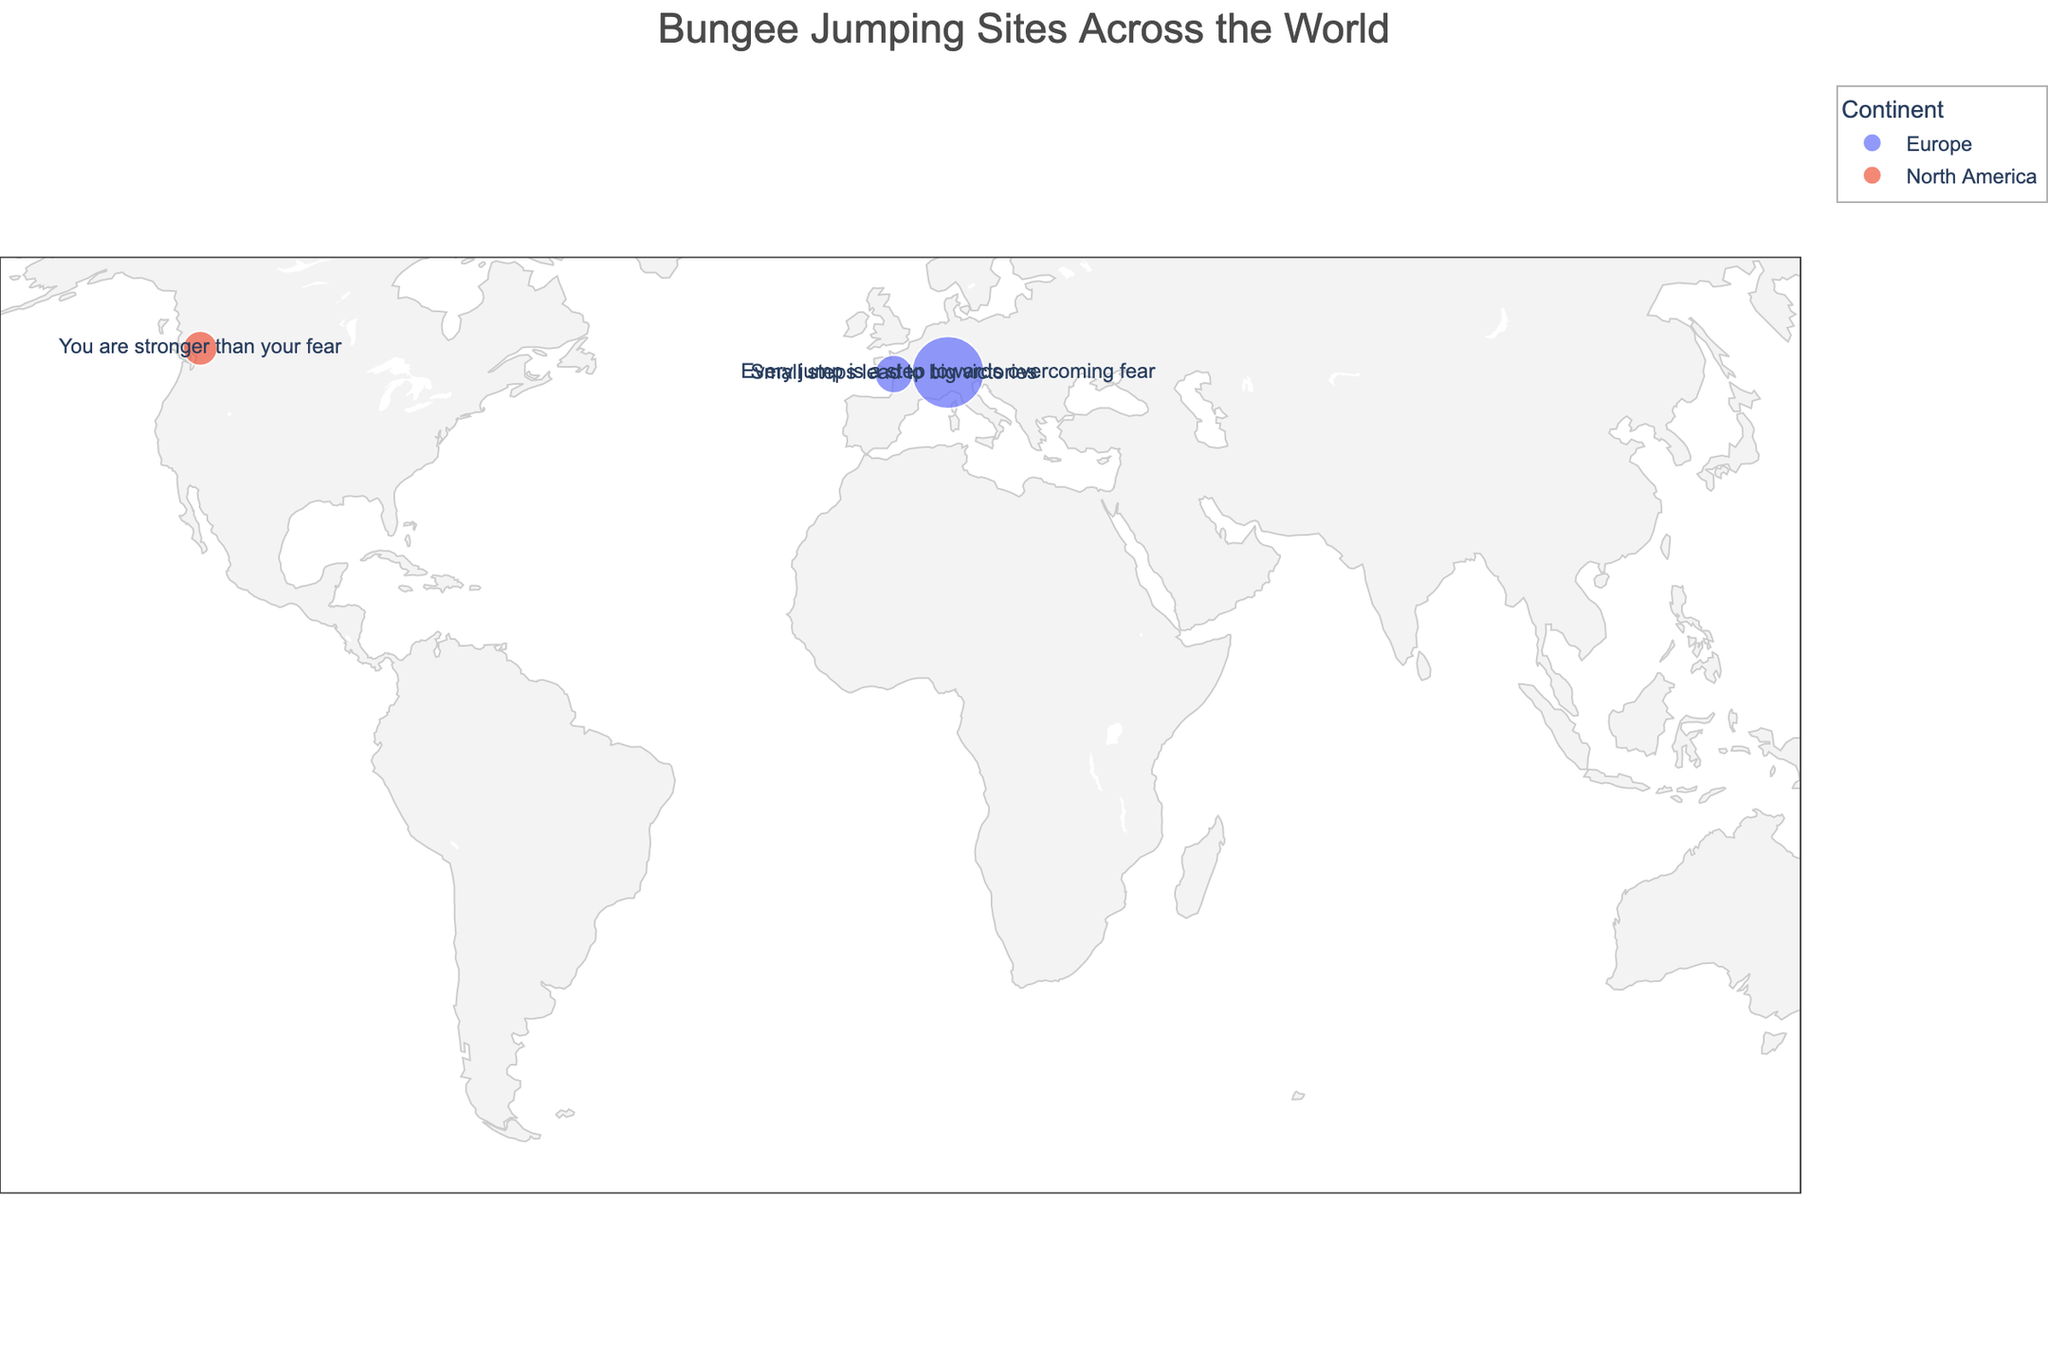What is the title of the figure? The title of the figure is usually displayed prominently at the top of the plot. In this case, the title indicated in the code provided is "Bungee Jumping Sites Across the World".
Answer: Bungee Jumping Sites Across the World Which continent has the highest jump? The height of each jump is represented by the size of the markers on the plot. The largest marker in the plot is 220 meters high, located in Switzerland, which is in Europe.
Answer: Europe How many bungee jumping sites are marked on the map? Counting each marker representing a bungee jumping site on the plot, we find there are three markers.
Answer: 3 Compare the bungee jumping heights between North America and Europe. Which has the higher average jump height? To compare the average heights, sum the heights of the jumps in each continent and divide by the number of jumps. Europe: (220 m + 61 m) / 2 = 140.5 m, North America: 50 m. Europe has a higher average jump height.
Answer: Europe What is the motivational quote associated with the highest jump height? By identifying the location with the highest jump height, Switzerland's Contra Dam at 220 m, we see the associated motivational quote is "Every jump is a step towards overcoming fear".
Answer: Every jump is a step towards overcoming fear Which bungee jumping site has the smallest jump height and what is its height? Identify the smallest marker on the plot, which represents the smallest jump height. The smallest jump height is marked for Whistler Bungee in Canada at 50 meters.
Answer: Whistler Bungee, 50 meters What is the most common continent for the bungee jumping sites in the figure? By counting the number of sites per continent, Europe has two sites while North America has one. Therefore, Europe is the most common continent in the figure.
Answer: Europe Compare the jump heights between the sites in Switzerland and France. Which is higher? Switzerland's Contra Dam has a jump height of 220 meters, and France's Viaduc de la Souleuvre has a jump height of 61 meters. Switzerland's jump height is higher.
Answer: Switzerland Determine the total jump height if you were to jump from every site in Europe. Sum the heights of the jumps in Europe: 220 meters (Switzerland) + 61 meters (France) = 281 meters.
Answer: 281 meters Which country has only one bungee jumping site shown on the map? From the data provided, Canada has only one site marked (Whistler Bungee). Therefore, Canada is the country with only one site.
Answer: Canada 